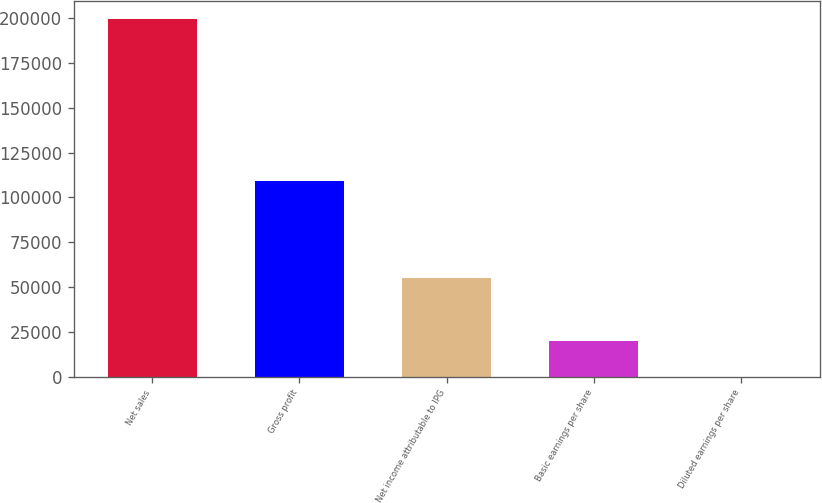Convert chart. <chart><loc_0><loc_0><loc_500><loc_500><bar_chart><fcel>Net sales<fcel>Gross profit<fcel>Net income attributable to IPG<fcel>Basic earnings per share<fcel>Diluted earnings per share<nl><fcel>199651<fcel>109090<fcel>55200<fcel>19966<fcel>1.05<nl></chart> 